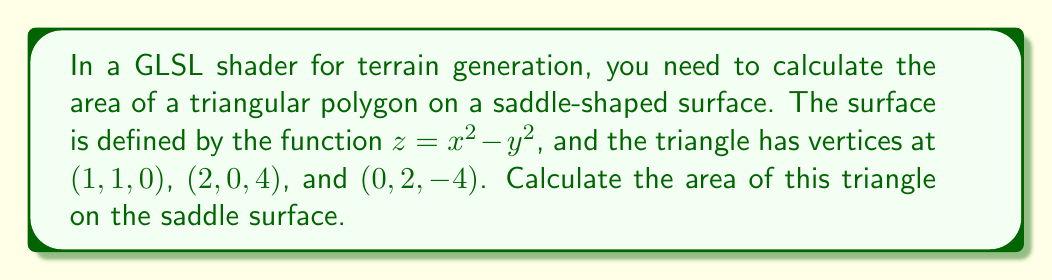What is the answer to this math problem? To calculate the area of a polygon on a curved surface, we need to use the following steps:

1. Find the vectors representing two sides of the triangle:
   $\vec{v} = (2-1, 0-1, 4-0) = (1, -1, 4)$
   $\vec{w} = (0-1, 2-1, -4-0) = (-1, 1, -4)$

2. Calculate the cross product of these vectors:
   $\vec{n} = \vec{v} \times \vec{w} = (0, 8, 2)$

3. Normalize the cross product:
   $\hat{n} = \frac{\vec{n}}{|\vec{n}|} = \frac{(0, 8, 2)}{\sqrt{0^2 + 8^2 + 2^2}} = (0, \frac{4}{\sqrt{68}}, \frac{1}{\sqrt{68}})$

4. Calculate the normal vector of the surface at each vertex:
   For $(x, y, z)$, the normal is $(2x, -2y, 1)$
   $N_1 = (2, -2, 1)$ at $(1, 1, 0)$
   $N_2 = (4, 0, 1)$ at $(2, 0, 4)$
   $N_3 = (0, -4, 1)$ at $(0, 2, -4)$

5. Calculate the average normal:
   $N_{avg} = \frac{1}{3}(N_1 + N_2 + N_3) = (\frac{2}{3}, -2, 1)$

6. Normalize the average normal:
   $\hat{N}_{avg} = \frac{N_{avg}}{|N_{avg}|} = (\frac{2}{3\sqrt{5}}, -\frac{2}{\sqrt{5}}, \frac{1}{\sqrt{5}})$

7. Calculate the dot product of $\hat{n}$ and $\hat{N}_{avg}$:
   $\cos{\theta} = \hat{n} \cdot \hat{N}_{avg} = \frac{4}{\sqrt{68}} \cdot (-\frac{2}{\sqrt{5}}) + \frac{1}{\sqrt{68}} \cdot \frac{1}{\sqrt{5}} = -\frac{7}{\sqrt{340}}$

8. Calculate the area:
   $\text{Area} = \frac{|\vec{n}|}{|\cos{\theta}|} = \frac{\sqrt{68}}{\frac{7}{\sqrt{340}}} = \frac{2\sqrt{5780}}{7}$
Answer: $\frac{2\sqrt{5780}}{7}$ square units 